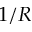<formula> <loc_0><loc_0><loc_500><loc_500>1 / R</formula> 